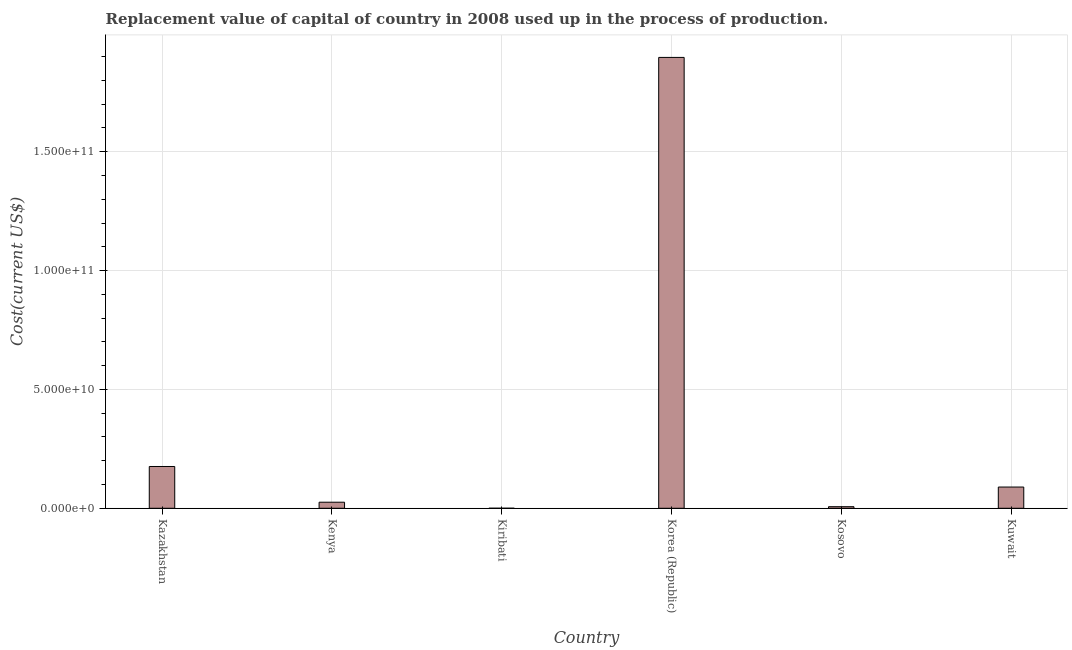Does the graph contain any zero values?
Your answer should be very brief. No. Does the graph contain grids?
Make the answer very short. Yes. What is the title of the graph?
Your response must be concise. Replacement value of capital of country in 2008 used up in the process of production. What is the label or title of the X-axis?
Your answer should be compact. Country. What is the label or title of the Y-axis?
Your answer should be compact. Cost(current US$). What is the consumption of fixed capital in Kenya?
Offer a terse response. 2.55e+09. Across all countries, what is the maximum consumption of fixed capital?
Provide a short and direct response. 1.90e+11. Across all countries, what is the minimum consumption of fixed capital?
Offer a very short reply. 9.27e+06. In which country was the consumption of fixed capital maximum?
Your response must be concise. Korea (Republic). In which country was the consumption of fixed capital minimum?
Offer a terse response. Kiribati. What is the sum of the consumption of fixed capital?
Provide a short and direct response. 2.19e+11. What is the difference between the consumption of fixed capital in Kosovo and Kuwait?
Provide a succinct answer. -8.27e+09. What is the average consumption of fixed capital per country?
Offer a terse response. 3.66e+1. What is the median consumption of fixed capital?
Ensure brevity in your answer.  5.74e+09. In how many countries, is the consumption of fixed capital greater than 180000000000 US$?
Provide a succinct answer. 1. What is the ratio of the consumption of fixed capital in Kazakhstan to that in Kiribati?
Keep it short and to the point. 1895.47. What is the difference between the highest and the second highest consumption of fixed capital?
Offer a very short reply. 1.72e+11. Is the sum of the consumption of fixed capital in Kazakhstan and Kiribati greater than the maximum consumption of fixed capital across all countries?
Your response must be concise. No. What is the difference between the highest and the lowest consumption of fixed capital?
Your answer should be very brief. 1.90e+11. What is the Cost(current US$) in Kazakhstan?
Provide a succinct answer. 1.76e+1. What is the Cost(current US$) of Kenya?
Provide a succinct answer. 2.55e+09. What is the Cost(current US$) of Kiribati?
Offer a terse response. 9.27e+06. What is the Cost(current US$) of Korea (Republic)?
Offer a terse response. 1.90e+11. What is the Cost(current US$) in Kosovo?
Your answer should be compact. 6.62e+08. What is the Cost(current US$) of Kuwait?
Offer a very short reply. 8.93e+09. What is the difference between the Cost(current US$) in Kazakhstan and Kenya?
Make the answer very short. 1.50e+1. What is the difference between the Cost(current US$) in Kazakhstan and Kiribati?
Provide a succinct answer. 1.76e+1. What is the difference between the Cost(current US$) in Kazakhstan and Korea (Republic)?
Give a very brief answer. -1.72e+11. What is the difference between the Cost(current US$) in Kazakhstan and Kosovo?
Offer a terse response. 1.69e+1. What is the difference between the Cost(current US$) in Kazakhstan and Kuwait?
Your response must be concise. 8.64e+09. What is the difference between the Cost(current US$) in Kenya and Kiribati?
Your answer should be compact. 2.54e+09. What is the difference between the Cost(current US$) in Kenya and Korea (Republic)?
Ensure brevity in your answer.  -1.87e+11. What is the difference between the Cost(current US$) in Kenya and Kosovo?
Give a very brief answer. 1.89e+09. What is the difference between the Cost(current US$) in Kenya and Kuwait?
Your response must be concise. -6.38e+09. What is the difference between the Cost(current US$) in Kiribati and Korea (Republic)?
Offer a terse response. -1.90e+11. What is the difference between the Cost(current US$) in Kiribati and Kosovo?
Ensure brevity in your answer.  -6.52e+08. What is the difference between the Cost(current US$) in Kiribati and Kuwait?
Keep it short and to the point. -8.92e+09. What is the difference between the Cost(current US$) in Korea (Republic) and Kosovo?
Give a very brief answer. 1.89e+11. What is the difference between the Cost(current US$) in Korea (Republic) and Kuwait?
Provide a succinct answer. 1.81e+11. What is the difference between the Cost(current US$) in Kosovo and Kuwait?
Offer a very short reply. -8.27e+09. What is the ratio of the Cost(current US$) in Kazakhstan to that in Kenya?
Make the answer very short. 6.89. What is the ratio of the Cost(current US$) in Kazakhstan to that in Kiribati?
Provide a succinct answer. 1895.47. What is the ratio of the Cost(current US$) in Kazakhstan to that in Korea (Republic)?
Give a very brief answer. 0.09. What is the ratio of the Cost(current US$) in Kazakhstan to that in Kosovo?
Provide a short and direct response. 26.55. What is the ratio of the Cost(current US$) in Kazakhstan to that in Kuwait?
Your response must be concise. 1.97. What is the ratio of the Cost(current US$) in Kenya to that in Kiribati?
Provide a succinct answer. 275.27. What is the ratio of the Cost(current US$) in Kenya to that in Korea (Republic)?
Offer a very short reply. 0.01. What is the ratio of the Cost(current US$) in Kenya to that in Kosovo?
Provide a succinct answer. 3.86. What is the ratio of the Cost(current US$) in Kenya to that in Kuwait?
Your response must be concise. 0.29. What is the ratio of the Cost(current US$) in Kiribati to that in Kosovo?
Offer a terse response. 0.01. What is the ratio of the Cost(current US$) in Kiribati to that in Kuwait?
Keep it short and to the point. 0. What is the ratio of the Cost(current US$) in Korea (Republic) to that in Kosovo?
Keep it short and to the point. 286.61. What is the ratio of the Cost(current US$) in Korea (Republic) to that in Kuwait?
Ensure brevity in your answer.  21.24. What is the ratio of the Cost(current US$) in Kosovo to that in Kuwait?
Offer a very short reply. 0.07. 